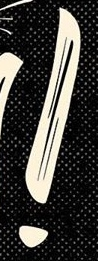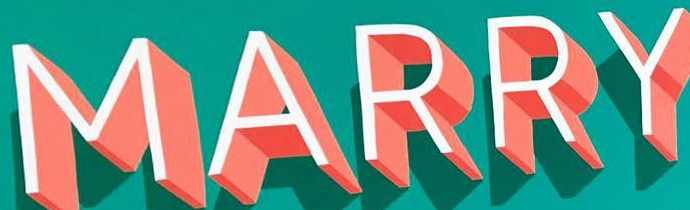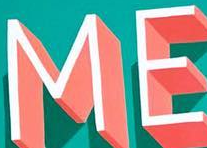What words can you see in these images in sequence, separated by a semicolon? !; MARRY; ME 